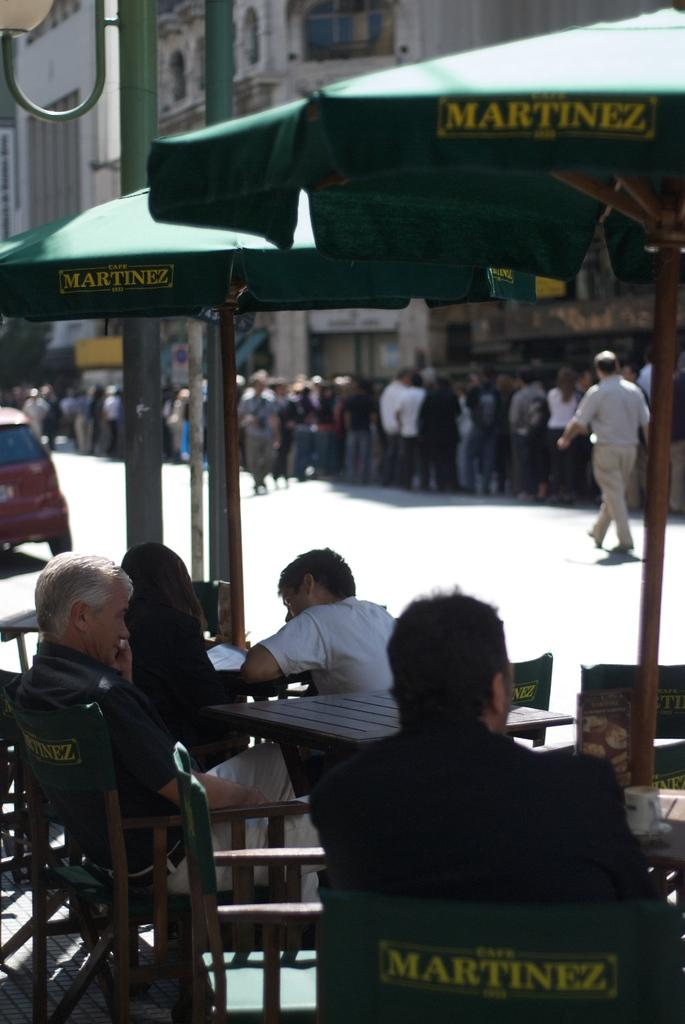What type of structures can be seen in the image? There are buildings in the image. What objects are present for protection from the elements? There are umbrellas in the image. Who or what is present near the umbrellas? There are people standing in the image. What type of furniture is visible in the image? There are chairs and tables in the image. What type of fruit is being used as a chess piece in the image? There is no fruit or chess game present in the image. How many beds can be seen in the image? There are no beds visible in the image. 